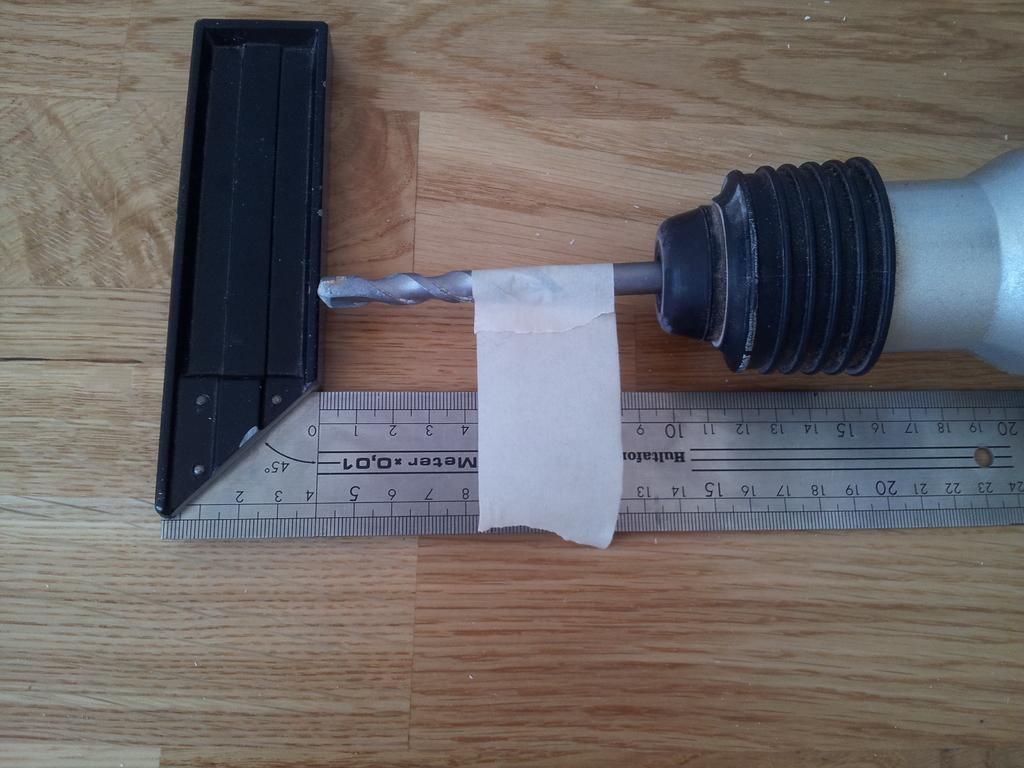<image>
Render a clear and concise summary of the photo. A drill with tape sits at a measuring tape, at between 8 and 13 centimetres. 